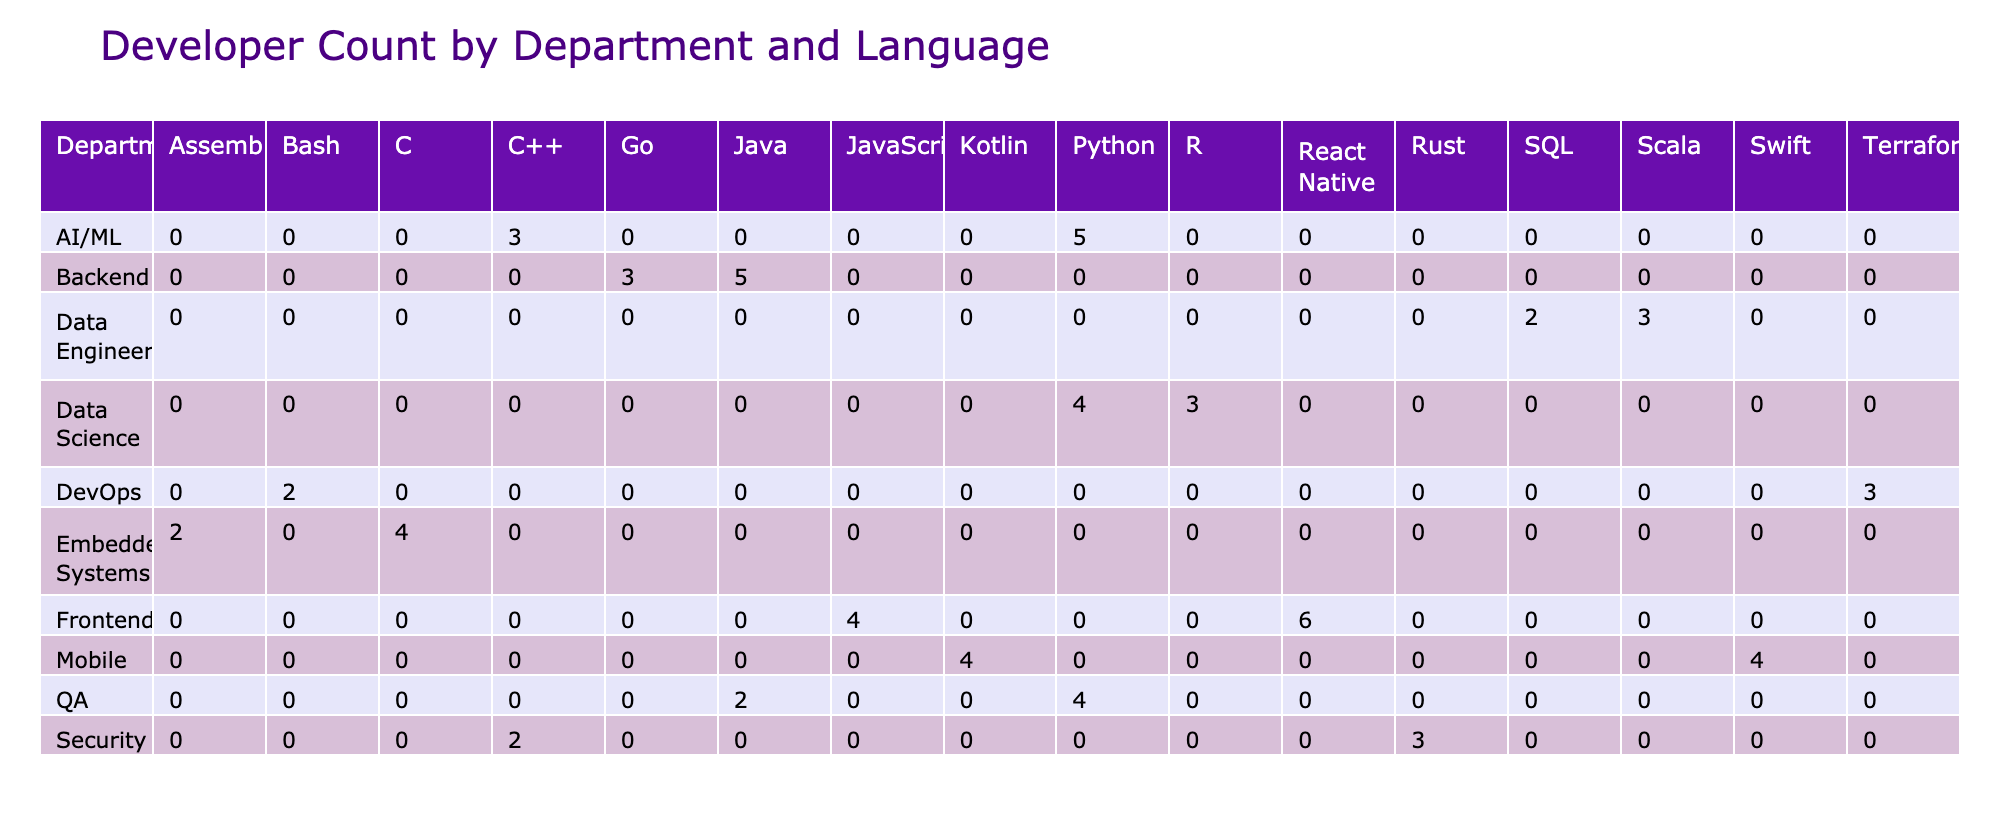What programming language has the highest developer count in the Backend department? In the Backend department, we look at the DeveloperCount for each language. Java has a count of 5, while Go has a count of 3. Therefore, Java has the highest count.
Answer: Java Which department has the lowest total developer count across all programming languages? We need to sum the DeveloperCount for each department. From the table, Backend has 8, Frontend has 10, Data Science has 7, DevOps has 5, QA has 6, Security has 5, Mobile has 8, Data Engineering has 5, and AI/ML has 8. The lowest total is for DevOps with a count of 5.
Answer: DevOps Is there a project in the Data Science department using Java? We check the projects listed under the Data Science department. The projects are Recommendation Engine (Python) and Fraud Detection (R). There is no project using Java in this department.
Answer: No How many more developers are working on frontend projects than on backend projects? We sum the DeveloperCount for Frontend (4+6=10) and Backend (5+3=8). The difference is 10 - 8 = 2, meaning there are 2 more developers on Frontend projects than Backend projects.
Answer: 2 Which programming language is used in the most projects within the Mobile department? We check the number of projects in the Mobile department, which are iOS App (Swift) and Android App (Kotlin). Since each language is represented by one project, there is no single language that is used in multiple projects in this department. Therefore, the count is equal.
Answer: No What is the total number of developers working with Python in the entire table? We find all occurrences of Python in the table: recommendation engine (4), automated testing (4), and AI/ML (5). The total count is 4 + 4 + 5 = 13.
Answer: 13 Is the usage of C++ more frequent than Rust across all departments? We check the DeveloperCount for C++ (2 in Security and 3 in AI/ML) totaling 5, whereas Rust is only used in one project with 3 developers. Therefore, C++ has more developers than Rust.
Answer: Yes Which department features the project with the longest duration? We check the ProjectDuration for each project across all departments. The maximum duration is 8 weeks for the Mobile App (Frontend) and AI/ML (Natural Language Processing), indicating two departments share this characteristic.
Answer: Mobile and AI/ML Is there any programming language with zero developers across all departments? We can see all listed languages have at least one developer assigned to them in the table. Therefore, there are no programming languages with zero developers.
Answer: No 